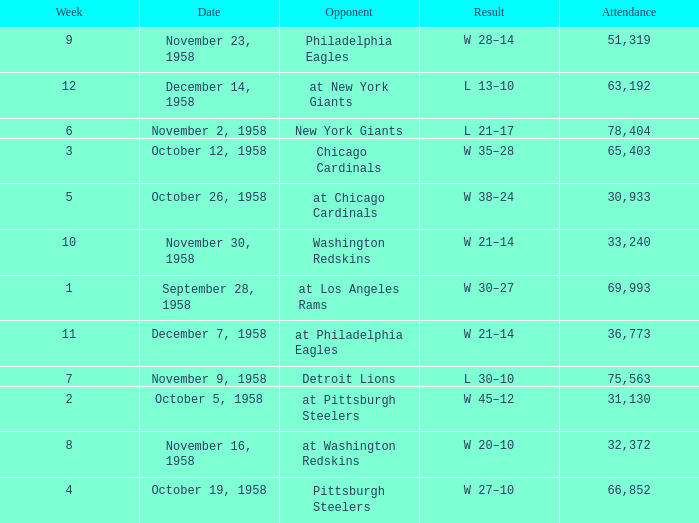What day had over 51,319 attending week 4? October 19, 1958. 